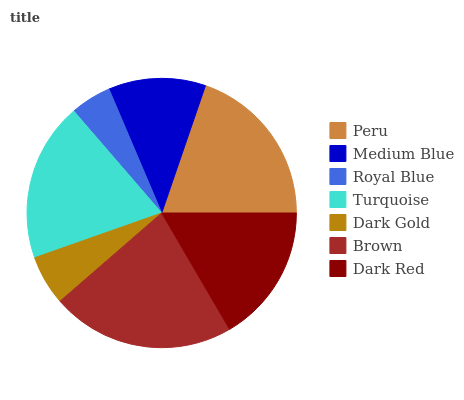Is Royal Blue the minimum?
Answer yes or no. Yes. Is Brown the maximum?
Answer yes or no. Yes. Is Medium Blue the minimum?
Answer yes or no. No. Is Medium Blue the maximum?
Answer yes or no. No. Is Peru greater than Medium Blue?
Answer yes or no. Yes. Is Medium Blue less than Peru?
Answer yes or no. Yes. Is Medium Blue greater than Peru?
Answer yes or no. No. Is Peru less than Medium Blue?
Answer yes or no. No. Is Dark Red the high median?
Answer yes or no. Yes. Is Dark Red the low median?
Answer yes or no. Yes. Is Dark Gold the high median?
Answer yes or no. No. Is Royal Blue the low median?
Answer yes or no. No. 